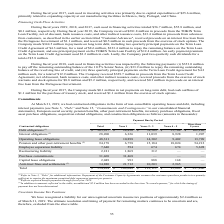According to Kemet Corporation's financial document, What did Pension and other post-retirement benefits reflect? expected benefit payments through fiscal year 2029.. The document states: "ed debt repayment amount per quarter. (2) Reflects expected benefit payments through fiscal year 2029. (3) In addition to amounts reflected in the tab..." Also, What were the total debt obligations? According to the financial document, 305,927 (in thousands). The relevant text states: "Debt obligations (1) $ 305,927 $ 28,430 $ 59,509 $ 55,708 $ 162,280..." Also, What were the interest obligations that had payments due more than 5 years? According to the financial document, 1,907 (in thousands). The relevant text states: "nterest obligations (1) 28,200 6,326 11,039 8,928 1,907..." Also, can you calculate: What was the difference in the total between Employee separation liability and Restructuring liability? Based on the calculation: 7,640-2,181, the result is 5459 (in thousands). This is based on the information: "Restructuring liability 2,181 1,869 312 — — Employee separation liability 7,640 594 674 674 5,698..." The key data points involved are: 2,181, 7,640. Also, can you calculate: What was the difference between the payments due by Year 1 between Interest obligations and operating lease obligations? Based on the calculation: 10,898-6,326, the result is 4572 (in thousands). This is based on the information: "Interest obligations (1) 28,200 6,326 11,039 8,928 1,907 Operating lease obligations 48,311 10,898 14,302 9,402 13,709..." The key data points involved are: 10,898, 6,326. Also, can you calculate: What were the total debt obligations as a percentage of the total contractual obligations? Based on the calculation: 305,927/554,834, the result is 55.14 (percentage). This is based on the information: "Debt obligations (1) $ 305,927 $ 28,430 $ 59,509 $ 55,708 $ 162,280 Total $ 554,834 $ 109,048 $ 112,111 $ 95,869 $ 237,806..." The key data points involved are: 305,927, 554,834. 